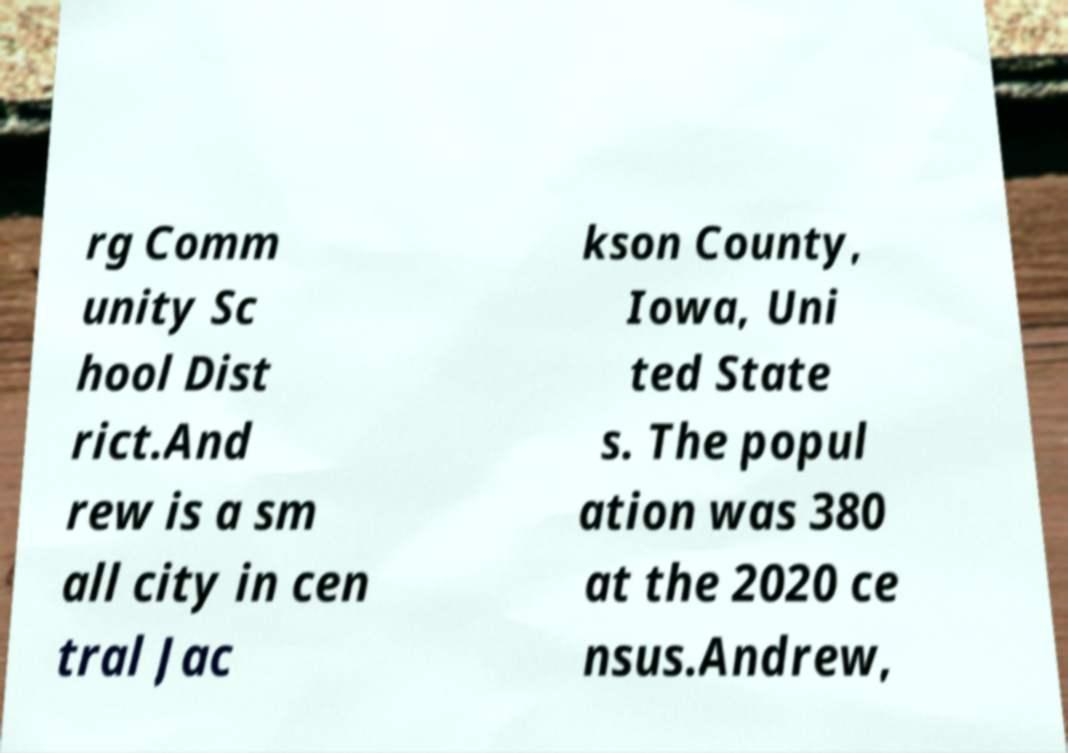Can you read and provide the text displayed in the image?This photo seems to have some interesting text. Can you extract and type it out for me? rg Comm unity Sc hool Dist rict.And rew is a sm all city in cen tral Jac kson County, Iowa, Uni ted State s. The popul ation was 380 at the 2020 ce nsus.Andrew, 